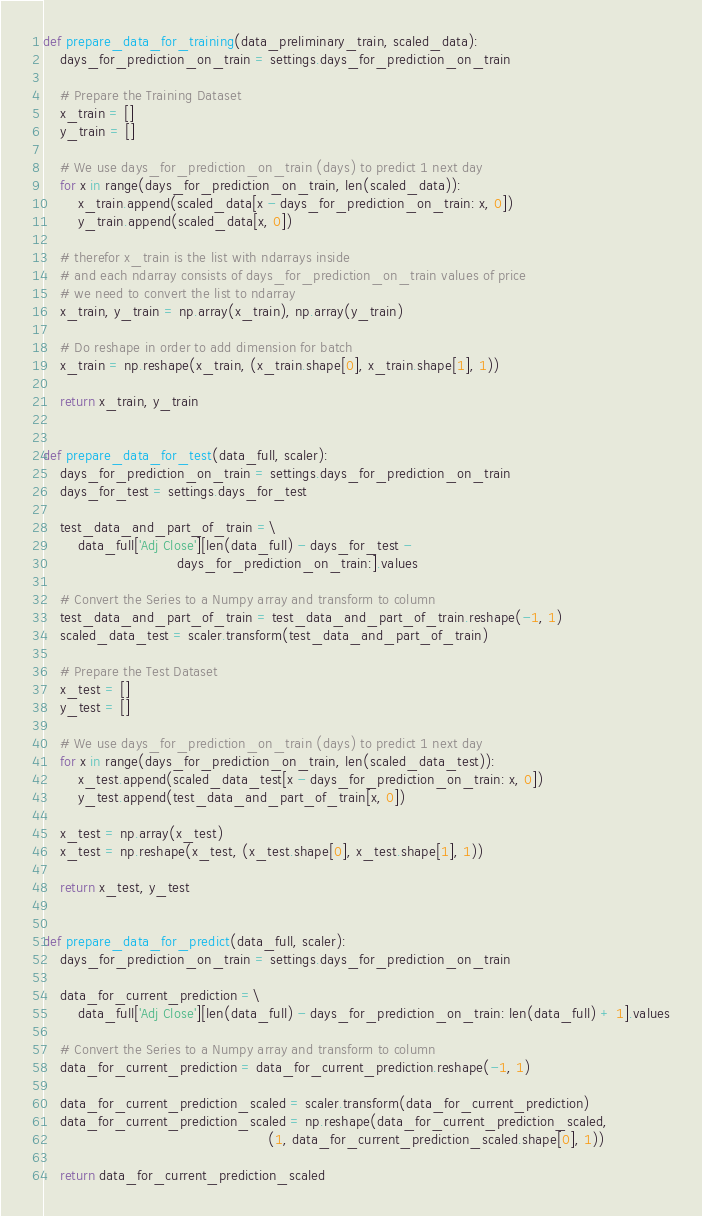Convert code to text. <code><loc_0><loc_0><loc_500><loc_500><_Python_>
def prepare_data_for_training(data_preliminary_train, scaled_data):
    days_for_prediction_on_train = settings.days_for_prediction_on_train

    # Prepare the Training Dataset
    x_train = []
    y_train = []

    # We use days_for_prediction_on_train (days) to predict 1 next day
    for x in range(days_for_prediction_on_train, len(scaled_data)):
        x_train.append(scaled_data[x - days_for_prediction_on_train: x, 0])
        y_train.append(scaled_data[x, 0])

    # therefor x_train is the list with ndarrays inside
    # and each ndarray consists of days_for_prediction_on_train values of price
    # we need to convert the list to ndarray
    x_train, y_train = np.array(x_train), np.array(y_train)

    # Do reshape in order to add dimension for batch
    x_train = np.reshape(x_train, (x_train.shape[0], x_train.shape[1], 1))

    return x_train, y_train


def prepare_data_for_test(data_full, scaler):
    days_for_prediction_on_train = settings.days_for_prediction_on_train
    days_for_test = settings.days_for_test

    test_data_and_part_of_train =\
        data_full['Adj Close'][len(data_full) - days_for_test -
                               days_for_prediction_on_train:].values

    # Convert the Series to a Numpy array and transform to column
    test_data_and_part_of_train = test_data_and_part_of_train.reshape(-1, 1)
    scaled_data_test = scaler.transform(test_data_and_part_of_train)

    # Prepare the Test Dataset
    x_test = []
    y_test = []

    # We use days_for_prediction_on_train (days) to predict 1 next day
    for x in range(days_for_prediction_on_train, len(scaled_data_test)):
        x_test.append(scaled_data_test[x - days_for_prediction_on_train: x, 0])
        y_test.append(test_data_and_part_of_train[x, 0])

    x_test = np.array(x_test)
    x_test = np.reshape(x_test, (x_test.shape[0], x_test.shape[1], 1))

    return x_test, y_test


def prepare_data_for_predict(data_full, scaler):
    days_for_prediction_on_train = settings.days_for_prediction_on_train

    data_for_current_prediction =\
        data_full['Adj Close'][len(data_full) - days_for_prediction_on_train: len(data_full) + 1].values

    # Convert the Series to a Numpy array and transform to column
    data_for_current_prediction = data_for_current_prediction.reshape(-1, 1)

    data_for_current_prediction_scaled = scaler.transform(data_for_current_prediction)
    data_for_current_prediction_scaled = np.reshape(data_for_current_prediction_scaled,
                                                    (1, data_for_current_prediction_scaled.shape[0], 1))

    return data_for_current_prediction_scaled

</code> 